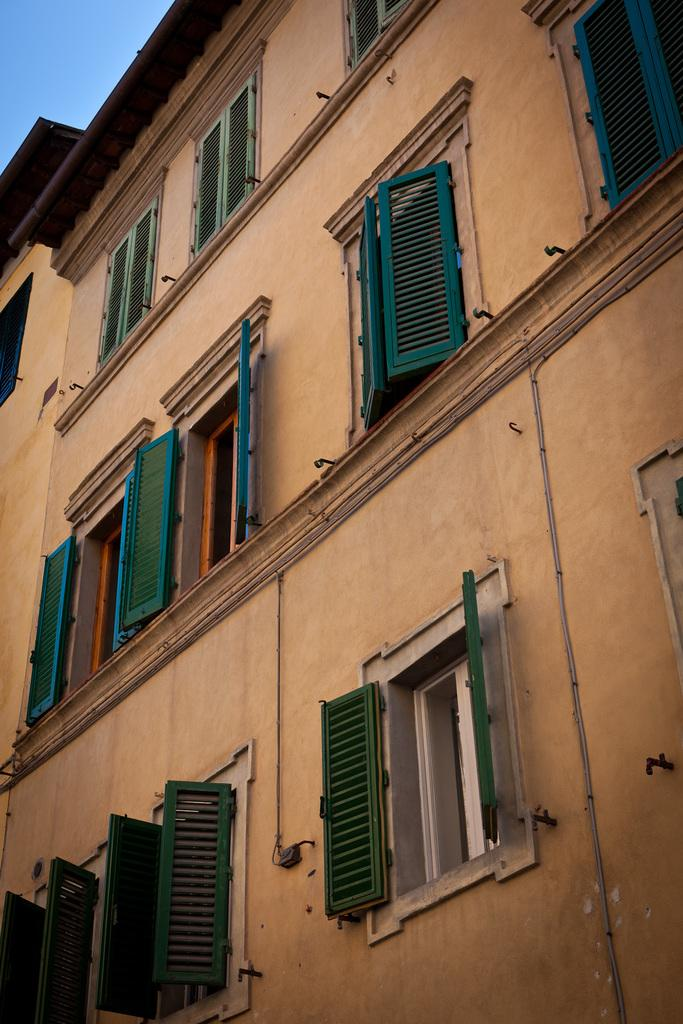What structure is the main subject of the image? There is a building in the image. What feature can be seen on the building? The building has windows. What is visible at the top of the image? The sky is visible at the top of the image. What type of tin can be seen on the roof of the building in the image? There is no tin visible on the roof of the building in the image. What question is being asked by the bucket in the image? There is no bucket present in the image, and therefore no questions are being asked by a bucket. 